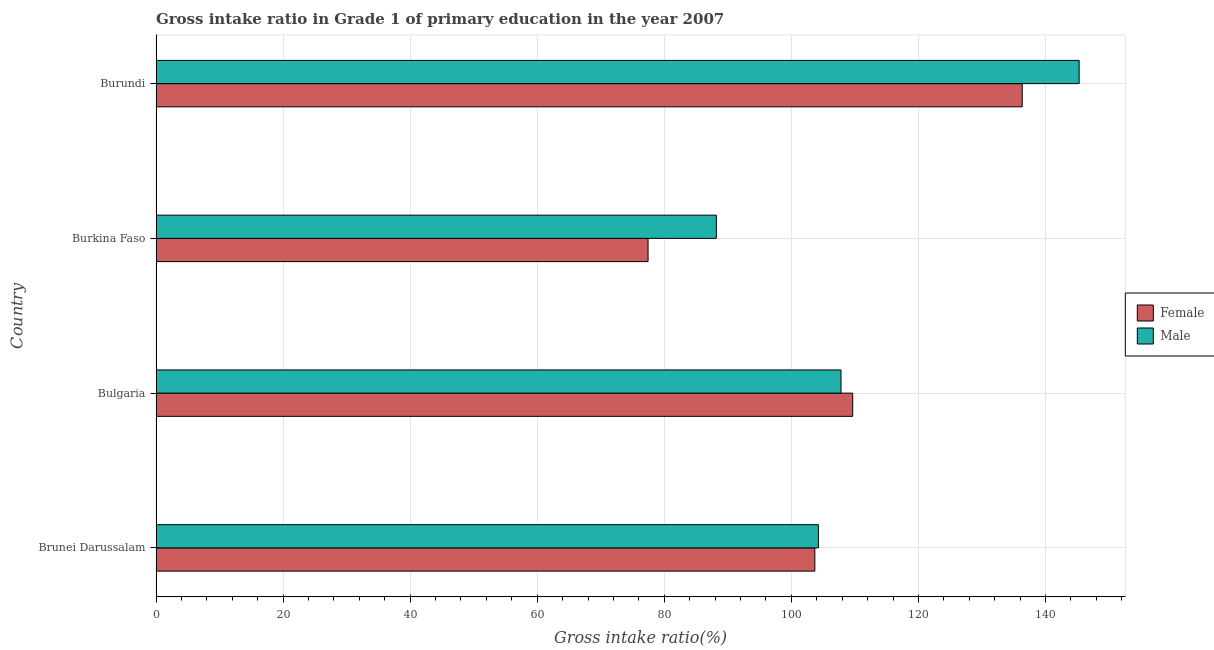How many different coloured bars are there?
Keep it short and to the point. 2. How many groups of bars are there?
Provide a short and direct response. 4. How many bars are there on the 3rd tick from the bottom?
Keep it short and to the point. 2. In how many cases, is the number of bars for a given country not equal to the number of legend labels?
Your answer should be very brief. 0. What is the gross intake ratio(female) in Brunei Darussalam?
Ensure brevity in your answer.  103.69. Across all countries, what is the maximum gross intake ratio(female)?
Provide a succinct answer. 136.34. Across all countries, what is the minimum gross intake ratio(female)?
Your answer should be compact. 77.45. In which country was the gross intake ratio(female) maximum?
Your answer should be very brief. Burundi. In which country was the gross intake ratio(male) minimum?
Your answer should be very brief. Burkina Faso. What is the total gross intake ratio(male) in the graph?
Your response must be concise. 445.57. What is the difference between the gross intake ratio(female) in Bulgaria and that in Burkina Faso?
Make the answer very short. 32.21. What is the difference between the gross intake ratio(male) in Burkina Faso and the gross intake ratio(female) in Brunei Darussalam?
Your answer should be very brief. -15.49. What is the average gross intake ratio(male) per country?
Provide a succinct answer. 111.39. What is the difference between the gross intake ratio(male) and gross intake ratio(female) in Burkina Faso?
Your answer should be very brief. 10.75. What is the ratio of the gross intake ratio(female) in Brunei Darussalam to that in Burundi?
Ensure brevity in your answer.  0.76. Is the gross intake ratio(male) in Bulgaria less than that in Burundi?
Ensure brevity in your answer.  Yes. Is the difference between the gross intake ratio(female) in Burkina Faso and Burundi greater than the difference between the gross intake ratio(male) in Burkina Faso and Burundi?
Your response must be concise. No. What is the difference between the highest and the second highest gross intake ratio(female)?
Provide a succinct answer. 26.68. What is the difference between the highest and the lowest gross intake ratio(male)?
Ensure brevity in your answer.  57.1. In how many countries, is the gross intake ratio(female) greater than the average gross intake ratio(female) taken over all countries?
Keep it short and to the point. 2. How many bars are there?
Keep it short and to the point. 8. Are all the bars in the graph horizontal?
Provide a succinct answer. Yes. Are the values on the major ticks of X-axis written in scientific E-notation?
Offer a terse response. No. Does the graph contain grids?
Your answer should be compact. Yes. What is the title of the graph?
Offer a very short reply. Gross intake ratio in Grade 1 of primary education in the year 2007. Does "Death rate" appear as one of the legend labels in the graph?
Ensure brevity in your answer.  No. What is the label or title of the X-axis?
Your answer should be very brief. Gross intake ratio(%). What is the Gross intake ratio(%) in Female in Brunei Darussalam?
Your answer should be compact. 103.69. What is the Gross intake ratio(%) in Male in Brunei Darussalam?
Your answer should be compact. 104.26. What is the Gross intake ratio(%) in Female in Bulgaria?
Ensure brevity in your answer.  109.66. What is the Gross intake ratio(%) in Male in Bulgaria?
Give a very brief answer. 107.81. What is the Gross intake ratio(%) in Female in Burkina Faso?
Make the answer very short. 77.45. What is the Gross intake ratio(%) of Male in Burkina Faso?
Provide a short and direct response. 88.2. What is the Gross intake ratio(%) of Female in Burundi?
Your response must be concise. 136.34. What is the Gross intake ratio(%) in Male in Burundi?
Make the answer very short. 145.3. Across all countries, what is the maximum Gross intake ratio(%) in Female?
Your answer should be very brief. 136.34. Across all countries, what is the maximum Gross intake ratio(%) of Male?
Give a very brief answer. 145.3. Across all countries, what is the minimum Gross intake ratio(%) of Female?
Keep it short and to the point. 77.45. Across all countries, what is the minimum Gross intake ratio(%) of Male?
Provide a short and direct response. 88.2. What is the total Gross intake ratio(%) in Female in the graph?
Make the answer very short. 427.13. What is the total Gross intake ratio(%) in Male in the graph?
Offer a terse response. 445.57. What is the difference between the Gross intake ratio(%) in Female in Brunei Darussalam and that in Bulgaria?
Keep it short and to the point. -5.96. What is the difference between the Gross intake ratio(%) of Male in Brunei Darussalam and that in Bulgaria?
Your answer should be very brief. -3.56. What is the difference between the Gross intake ratio(%) in Female in Brunei Darussalam and that in Burkina Faso?
Provide a short and direct response. 26.25. What is the difference between the Gross intake ratio(%) in Male in Brunei Darussalam and that in Burkina Faso?
Provide a succinct answer. 16.06. What is the difference between the Gross intake ratio(%) of Female in Brunei Darussalam and that in Burundi?
Make the answer very short. -32.64. What is the difference between the Gross intake ratio(%) of Male in Brunei Darussalam and that in Burundi?
Make the answer very short. -41.04. What is the difference between the Gross intake ratio(%) of Female in Bulgaria and that in Burkina Faso?
Give a very brief answer. 32.21. What is the difference between the Gross intake ratio(%) in Male in Bulgaria and that in Burkina Faso?
Make the answer very short. 19.61. What is the difference between the Gross intake ratio(%) of Female in Bulgaria and that in Burundi?
Your response must be concise. -26.68. What is the difference between the Gross intake ratio(%) in Male in Bulgaria and that in Burundi?
Ensure brevity in your answer.  -37.48. What is the difference between the Gross intake ratio(%) of Female in Burkina Faso and that in Burundi?
Your answer should be compact. -58.89. What is the difference between the Gross intake ratio(%) of Male in Burkina Faso and that in Burundi?
Your answer should be very brief. -57.1. What is the difference between the Gross intake ratio(%) in Female in Brunei Darussalam and the Gross intake ratio(%) in Male in Bulgaria?
Your answer should be very brief. -4.12. What is the difference between the Gross intake ratio(%) in Female in Brunei Darussalam and the Gross intake ratio(%) in Male in Burkina Faso?
Provide a succinct answer. 15.49. What is the difference between the Gross intake ratio(%) of Female in Brunei Darussalam and the Gross intake ratio(%) of Male in Burundi?
Ensure brevity in your answer.  -41.6. What is the difference between the Gross intake ratio(%) in Female in Bulgaria and the Gross intake ratio(%) in Male in Burkina Faso?
Give a very brief answer. 21.46. What is the difference between the Gross intake ratio(%) of Female in Bulgaria and the Gross intake ratio(%) of Male in Burundi?
Provide a short and direct response. -35.64. What is the difference between the Gross intake ratio(%) of Female in Burkina Faso and the Gross intake ratio(%) of Male in Burundi?
Your answer should be very brief. -67.85. What is the average Gross intake ratio(%) of Female per country?
Offer a very short reply. 106.78. What is the average Gross intake ratio(%) of Male per country?
Your response must be concise. 111.39. What is the difference between the Gross intake ratio(%) of Female and Gross intake ratio(%) of Male in Brunei Darussalam?
Ensure brevity in your answer.  -0.56. What is the difference between the Gross intake ratio(%) in Female and Gross intake ratio(%) in Male in Bulgaria?
Give a very brief answer. 1.84. What is the difference between the Gross intake ratio(%) in Female and Gross intake ratio(%) in Male in Burkina Faso?
Your answer should be compact. -10.75. What is the difference between the Gross intake ratio(%) in Female and Gross intake ratio(%) in Male in Burundi?
Provide a short and direct response. -8.96. What is the ratio of the Gross intake ratio(%) in Female in Brunei Darussalam to that in Bulgaria?
Offer a terse response. 0.95. What is the ratio of the Gross intake ratio(%) in Female in Brunei Darussalam to that in Burkina Faso?
Give a very brief answer. 1.34. What is the ratio of the Gross intake ratio(%) in Male in Brunei Darussalam to that in Burkina Faso?
Provide a short and direct response. 1.18. What is the ratio of the Gross intake ratio(%) in Female in Brunei Darussalam to that in Burundi?
Offer a very short reply. 0.76. What is the ratio of the Gross intake ratio(%) of Male in Brunei Darussalam to that in Burundi?
Your answer should be compact. 0.72. What is the ratio of the Gross intake ratio(%) of Female in Bulgaria to that in Burkina Faso?
Your answer should be compact. 1.42. What is the ratio of the Gross intake ratio(%) in Male in Bulgaria to that in Burkina Faso?
Your answer should be very brief. 1.22. What is the ratio of the Gross intake ratio(%) of Female in Bulgaria to that in Burundi?
Your answer should be compact. 0.8. What is the ratio of the Gross intake ratio(%) in Male in Bulgaria to that in Burundi?
Offer a very short reply. 0.74. What is the ratio of the Gross intake ratio(%) of Female in Burkina Faso to that in Burundi?
Keep it short and to the point. 0.57. What is the ratio of the Gross intake ratio(%) in Male in Burkina Faso to that in Burundi?
Give a very brief answer. 0.61. What is the difference between the highest and the second highest Gross intake ratio(%) in Female?
Provide a succinct answer. 26.68. What is the difference between the highest and the second highest Gross intake ratio(%) in Male?
Give a very brief answer. 37.48. What is the difference between the highest and the lowest Gross intake ratio(%) of Female?
Make the answer very short. 58.89. What is the difference between the highest and the lowest Gross intake ratio(%) in Male?
Offer a terse response. 57.1. 